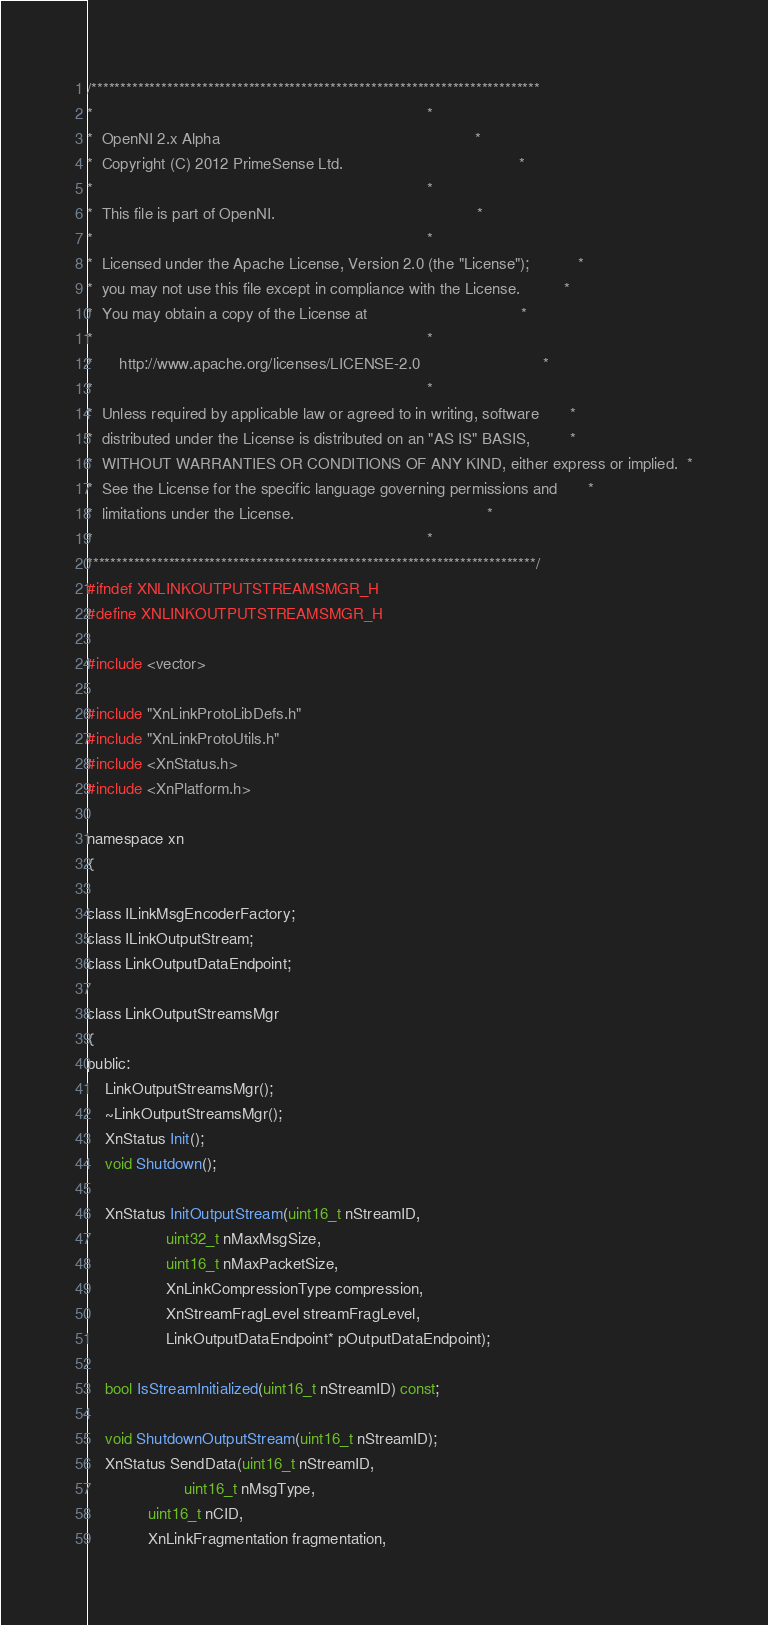<code> <loc_0><loc_0><loc_500><loc_500><_C_>/*****************************************************************************
*                                                                            *
*  OpenNI 2.x Alpha                                                          *
*  Copyright (C) 2012 PrimeSense Ltd.                                        *
*                                                                            *
*  This file is part of OpenNI.                                              *
*                                                                            *
*  Licensed under the Apache License, Version 2.0 (the "License");           *
*  you may not use this file except in compliance with the License.          *
*  You may obtain a copy of the License at                                   *
*                                                                            *
*      http://www.apache.org/licenses/LICENSE-2.0                            *
*                                                                            *
*  Unless required by applicable law or agreed to in writing, software       *
*  distributed under the License is distributed on an "AS IS" BASIS,         *
*  WITHOUT WARRANTIES OR CONDITIONS OF ANY KIND, either express or implied.  *
*  See the License for the specific language governing permissions and       *
*  limitations under the License.                                            *
*                                                                            *
*****************************************************************************/
#ifndef XNLINKOUTPUTSTREAMSMGR_H
#define XNLINKOUTPUTSTREAMSMGR_H

#include <vector>

#include "XnLinkProtoLibDefs.h"
#include "XnLinkProtoUtils.h"
#include <XnStatus.h>
#include <XnPlatform.h>

namespace xn
{

class ILinkMsgEncoderFactory;
class ILinkOutputStream;
class LinkOutputDataEndpoint;

class LinkOutputStreamsMgr
{
public:
	LinkOutputStreamsMgr();
	~LinkOutputStreamsMgr();
	XnStatus Init();
	void Shutdown();

	XnStatus InitOutputStream(uint16_t nStreamID,
				  uint32_t nMaxMsgSize,
				  uint16_t nMaxPacketSize,
				  XnLinkCompressionType compression,
				  XnStreamFragLevel streamFragLevel,
				  LinkOutputDataEndpoint* pOutputDataEndpoint);

	bool IsStreamInitialized(uint16_t nStreamID) const;

	void ShutdownOutputStream(uint16_t nStreamID);
	XnStatus SendData(uint16_t nStreamID,
	                  uint16_t nMsgType,
			  uint16_t nCID,
			  XnLinkFragmentation fragmentation,</code> 